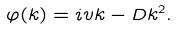Convert formula to latex. <formula><loc_0><loc_0><loc_500><loc_500>\varphi ( k ) = i v k - D k ^ { 2 } .</formula> 